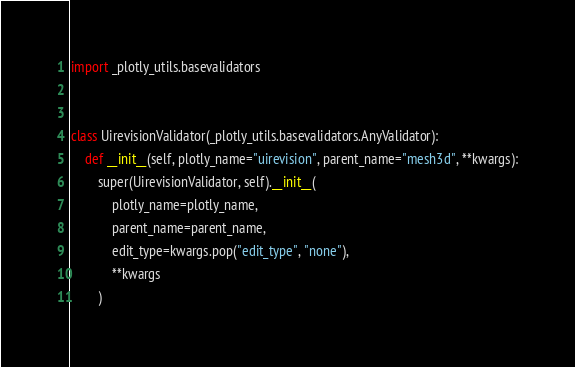<code> <loc_0><loc_0><loc_500><loc_500><_Python_>import _plotly_utils.basevalidators


class UirevisionValidator(_plotly_utils.basevalidators.AnyValidator):
    def __init__(self, plotly_name="uirevision", parent_name="mesh3d", **kwargs):
        super(UirevisionValidator, self).__init__(
            plotly_name=plotly_name,
            parent_name=parent_name,
            edit_type=kwargs.pop("edit_type", "none"),
            **kwargs
        )
</code> 